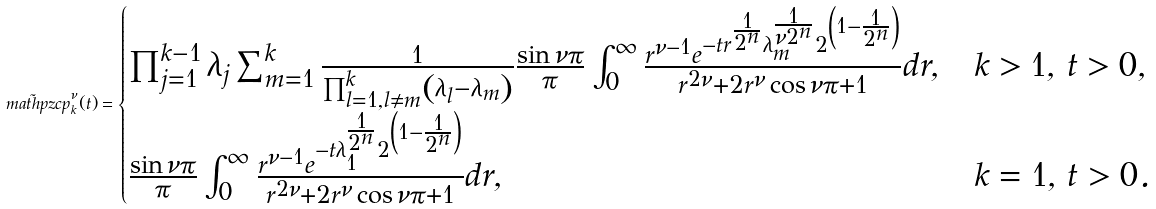<formula> <loc_0><loc_0><loc_500><loc_500>\tilde { \ m a t h p z c { p } } _ { k } ^ { \nu } ( t ) = \begin{cases} \prod _ { j = 1 } ^ { k - 1 } \lambda _ { j } \sum _ { m = 1 } ^ { k } \frac { 1 } { \prod _ { l = 1 , l \neq m } ^ { k } \left ( \lambda _ { l } - \lambda _ { m } \right ) } \frac { \sin \nu \pi } { \pi } \int _ { 0 } ^ { \infty } \frac { r ^ { \nu - 1 } e ^ { - t r ^ { \frac { 1 } { 2 ^ { n } } } \lambda _ { m } ^ { \frac { 1 } { \nu 2 ^ { n } } } 2 ^ { \left ( 1 - \frac { 1 } { 2 ^ { n } } \right ) } } } { r ^ { 2 \nu } + 2 r ^ { \nu } \cos \nu \pi + 1 } d r , & k > 1 , \, t > 0 , \\ \frac { \sin \nu \pi } { \pi } \int _ { 0 } ^ { \infty } \frac { r ^ { \nu - 1 } e ^ { - t \lambda _ { 1 } ^ { \frac { 1 } { 2 ^ { n } } } 2 ^ { \left ( 1 - \frac { 1 } { 2 ^ { n } } \right ) } } } { r ^ { 2 \nu } + 2 r ^ { \nu } \cos \nu \pi + 1 } d r , & k = 1 , \, t > 0 . \end{cases}</formula> 